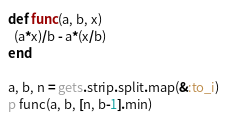Convert code to text. <code><loc_0><loc_0><loc_500><loc_500><_Ruby_>def func(a, b, x)
  (a*x)/b - a*(x/b)
end

a, b, n = gets.strip.split.map(&:to_i)
p func(a, b, [n, b-1].min)</code> 